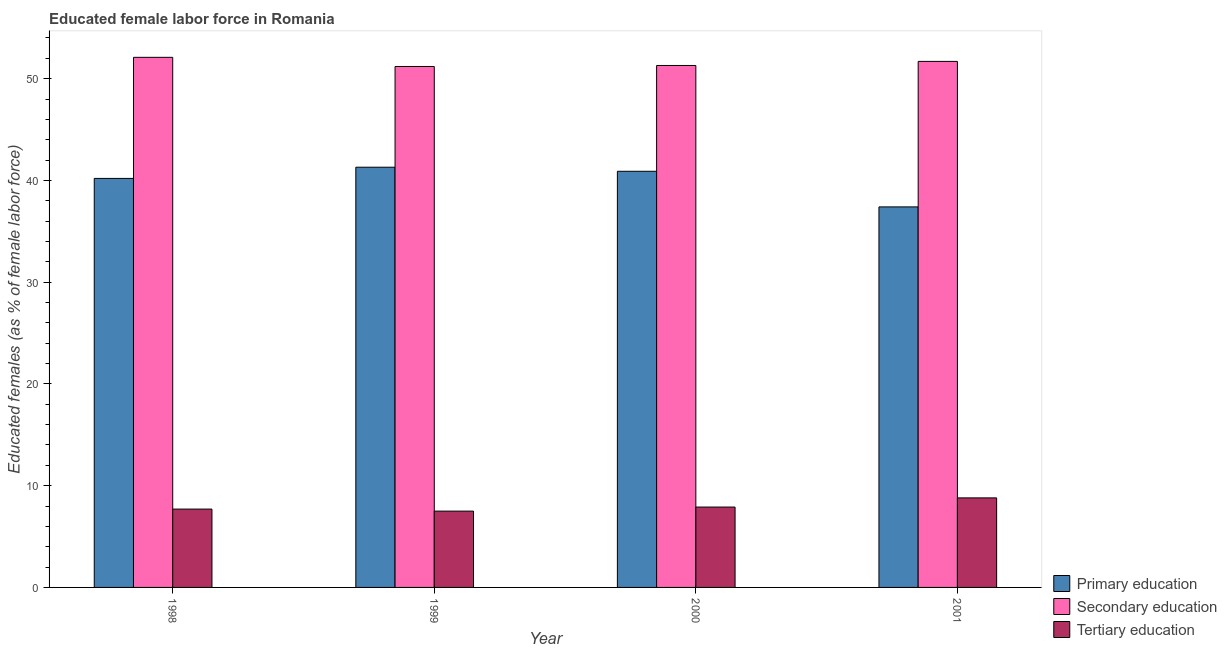How many groups of bars are there?
Keep it short and to the point. 4. Are the number of bars per tick equal to the number of legend labels?
Your response must be concise. Yes. Are the number of bars on each tick of the X-axis equal?
Make the answer very short. Yes. How many bars are there on the 4th tick from the left?
Provide a succinct answer. 3. What is the label of the 3rd group of bars from the left?
Offer a terse response. 2000. What is the percentage of female labor force who received tertiary education in 2000?
Ensure brevity in your answer.  7.9. Across all years, what is the maximum percentage of female labor force who received primary education?
Offer a very short reply. 41.3. Across all years, what is the minimum percentage of female labor force who received secondary education?
Keep it short and to the point. 51.2. What is the total percentage of female labor force who received secondary education in the graph?
Offer a very short reply. 206.3. What is the difference between the percentage of female labor force who received tertiary education in 1999 and that in 2000?
Ensure brevity in your answer.  -0.4. What is the difference between the percentage of female labor force who received secondary education in 1999 and the percentage of female labor force who received primary education in 2001?
Your response must be concise. -0.5. What is the average percentage of female labor force who received tertiary education per year?
Ensure brevity in your answer.  7.98. In the year 2000, what is the difference between the percentage of female labor force who received secondary education and percentage of female labor force who received primary education?
Offer a very short reply. 0. In how many years, is the percentage of female labor force who received primary education greater than 16 %?
Your answer should be very brief. 4. What is the ratio of the percentage of female labor force who received primary education in 1998 to that in 2001?
Offer a terse response. 1.07. Is the percentage of female labor force who received tertiary education in 1999 less than that in 2001?
Your response must be concise. Yes. What is the difference between the highest and the second highest percentage of female labor force who received secondary education?
Your answer should be compact. 0.4. What is the difference between the highest and the lowest percentage of female labor force who received primary education?
Provide a short and direct response. 3.9. Is the sum of the percentage of female labor force who received primary education in 1999 and 2001 greater than the maximum percentage of female labor force who received tertiary education across all years?
Provide a short and direct response. Yes. What does the 2nd bar from the left in 1999 represents?
Your response must be concise. Secondary education. What does the 1st bar from the right in 2001 represents?
Offer a very short reply. Tertiary education. Are all the bars in the graph horizontal?
Make the answer very short. No. Where does the legend appear in the graph?
Your response must be concise. Bottom right. How many legend labels are there?
Your answer should be very brief. 3. What is the title of the graph?
Ensure brevity in your answer.  Educated female labor force in Romania. What is the label or title of the X-axis?
Your answer should be very brief. Year. What is the label or title of the Y-axis?
Your answer should be compact. Educated females (as % of female labor force). What is the Educated females (as % of female labor force) in Primary education in 1998?
Give a very brief answer. 40.2. What is the Educated females (as % of female labor force) of Secondary education in 1998?
Offer a terse response. 52.1. What is the Educated females (as % of female labor force) in Tertiary education in 1998?
Your answer should be compact. 7.7. What is the Educated females (as % of female labor force) in Primary education in 1999?
Keep it short and to the point. 41.3. What is the Educated females (as % of female labor force) in Secondary education in 1999?
Offer a very short reply. 51.2. What is the Educated females (as % of female labor force) in Primary education in 2000?
Provide a short and direct response. 40.9. What is the Educated females (as % of female labor force) in Secondary education in 2000?
Offer a terse response. 51.3. What is the Educated females (as % of female labor force) in Tertiary education in 2000?
Offer a very short reply. 7.9. What is the Educated females (as % of female labor force) of Primary education in 2001?
Offer a terse response. 37.4. What is the Educated females (as % of female labor force) of Secondary education in 2001?
Your answer should be very brief. 51.7. What is the Educated females (as % of female labor force) of Tertiary education in 2001?
Provide a short and direct response. 8.8. Across all years, what is the maximum Educated females (as % of female labor force) in Primary education?
Provide a short and direct response. 41.3. Across all years, what is the maximum Educated females (as % of female labor force) of Secondary education?
Your response must be concise. 52.1. Across all years, what is the maximum Educated females (as % of female labor force) in Tertiary education?
Your answer should be compact. 8.8. Across all years, what is the minimum Educated females (as % of female labor force) of Primary education?
Your answer should be compact. 37.4. Across all years, what is the minimum Educated females (as % of female labor force) of Secondary education?
Your answer should be very brief. 51.2. Across all years, what is the minimum Educated females (as % of female labor force) of Tertiary education?
Offer a terse response. 7.5. What is the total Educated females (as % of female labor force) in Primary education in the graph?
Keep it short and to the point. 159.8. What is the total Educated females (as % of female labor force) of Secondary education in the graph?
Offer a terse response. 206.3. What is the total Educated females (as % of female labor force) of Tertiary education in the graph?
Offer a very short reply. 31.9. What is the difference between the Educated females (as % of female labor force) of Primary education in 1998 and that in 1999?
Offer a terse response. -1.1. What is the difference between the Educated females (as % of female labor force) in Secondary education in 1998 and that in 2000?
Offer a very short reply. 0.8. What is the difference between the Educated females (as % of female labor force) of Tertiary education in 1998 and that in 2000?
Provide a short and direct response. -0.2. What is the difference between the Educated females (as % of female labor force) of Secondary education in 1998 and that in 2001?
Keep it short and to the point. 0.4. What is the difference between the Educated females (as % of female labor force) of Secondary education in 1999 and that in 2000?
Your response must be concise. -0.1. What is the difference between the Educated females (as % of female labor force) in Tertiary education in 1999 and that in 2000?
Make the answer very short. -0.4. What is the difference between the Educated females (as % of female labor force) in Primary education in 1999 and that in 2001?
Ensure brevity in your answer.  3.9. What is the difference between the Educated females (as % of female labor force) of Secondary education in 1999 and that in 2001?
Offer a very short reply. -0.5. What is the difference between the Educated females (as % of female labor force) of Primary education in 1998 and the Educated females (as % of female labor force) of Secondary education in 1999?
Your response must be concise. -11. What is the difference between the Educated females (as % of female labor force) in Primary education in 1998 and the Educated females (as % of female labor force) in Tertiary education in 1999?
Offer a terse response. 32.7. What is the difference between the Educated females (as % of female labor force) in Secondary education in 1998 and the Educated females (as % of female labor force) in Tertiary education in 1999?
Your answer should be very brief. 44.6. What is the difference between the Educated females (as % of female labor force) of Primary education in 1998 and the Educated females (as % of female labor force) of Secondary education in 2000?
Your answer should be compact. -11.1. What is the difference between the Educated females (as % of female labor force) of Primary education in 1998 and the Educated females (as % of female labor force) of Tertiary education in 2000?
Make the answer very short. 32.3. What is the difference between the Educated females (as % of female labor force) in Secondary education in 1998 and the Educated females (as % of female labor force) in Tertiary education in 2000?
Ensure brevity in your answer.  44.2. What is the difference between the Educated females (as % of female labor force) in Primary education in 1998 and the Educated females (as % of female labor force) in Tertiary education in 2001?
Ensure brevity in your answer.  31.4. What is the difference between the Educated females (as % of female labor force) of Secondary education in 1998 and the Educated females (as % of female labor force) of Tertiary education in 2001?
Give a very brief answer. 43.3. What is the difference between the Educated females (as % of female labor force) of Primary education in 1999 and the Educated females (as % of female labor force) of Tertiary education in 2000?
Your answer should be compact. 33.4. What is the difference between the Educated females (as % of female labor force) of Secondary education in 1999 and the Educated females (as % of female labor force) of Tertiary education in 2000?
Offer a very short reply. 43.3. What is the difference between the Educated females (as % of female labor force) of Primary education in 1999 and the Educated females (as % of female labor force) of Tertiary education in 2001?
Your answer should be very brief. 32.5. What is the difference between the Educated females (as % of female labor force) in Secondary education in 1999 and the Educated females (as % of female labor force) in Tertiary education in 2001?
Your answer should be very brief. 42.4. What is the difference between the Educated females (as % of female labor force) in Primary education in 2000 and the Educated females (as % of female labor force) in Tertiary education in 2001?
Your response must be concise. 32.1. What is the difference between the Educated females (as % of female labor force) in Secondary education in 2000 and the Educated females (as % of female labor force) in Tertiary education in 2001?
Your answer should be very brief. 42.5. What is the average Educated females (as % of female labor force) in Primary education per year?
Your response must be concise. 39.95. What is the average Educated females (as % of female labor force) of Secondary education per year?
Your answer should be compact. 51.58. What is the average Educated females (as % of female labor force) of Tertiary education per year?
Your answer should be compact. 7.97. In the year 1998, what is the difference between the Educated females (as % of female labor force) of Primary education and Educated females (as % of female labor force) of Tertiary education?
Your answer should be compact. 32.5. In the year 1998, what is the difference between the Educated females (as % of female labor force) of Secondary education and Educated females (as % of female labor force) of Tertiary education?
Give a very brief answer. 44.4. In the year 1999, what is the difference between the Educated females (as % of female labor force) of Primary education and Educated females (as % of female labor force) of Tertiary education?
Your response must be concise. 33.8. In the year 1999, what is the difference between the Educated females (as % of female labor force) in Secondary education and Educated females (as % of female labor force) in Tertiary education?
Offer a very short reply. 43.7. In the year 2000, what is the difference between the Educated females (as % of female labor force) in Primary education and Educated females (as % of female labor force) in Secondary education?
Offer a terse response. -10.4. In the year 2000, what is the difference between the Educated females (as % of female labor force) of Primary education and Educated females (as % of female labor force) of Tertiary education?
Keep it short and to the point. 33. In the year 2000, what is the difference between the Educated females (as % of female labor force) of Secondary education and Educated females (as % of female labor force) of Tertiary education?
Make the answer very short. 43.4. In the year 2001, what is the difference between the Educated females (as % of female labor force) in Primary education and Educated females (as % of female labor force) in Secondary education?
Offer a very short reply. -14.3. In the year 2001, what is the difference between the Educated females (as % of female labor force) in Primary education and Educated females (as % of female labor force) in Tertiary education?
Give a very brief answer. 28.6. In the year 2001, what is the difference between the Educated females (as % of female labor force) in Secondary education and Educated females (as % of female labor force) in Tertiary education?
Ensure brevity in your answer.  42.9. What is the ratio of the Educated females (as % of female labor force) in Primary education in 1998 to that in 1999?
Offer a very short reply. 0.97. What is the ratio of the Educated females (as % of female labor force) of Secondary education in 1998 to that in 1999?
Your answer should be compact. 1.02. What is the ratio of the Educated females (as % of female labor force) of Tertiary education in 1998 to that in 1999?
Your response must be concise. 1.03. What is the ratio of the Educated females (as % of female labor force) in Primary education in 1998 to that in 2000?
Provide a short and direct response. 0.98. What is the ratio of the Educated females (as % of female labor force) of Secondary education in 1998 to that in 2000?
Your answer should be very brief. 1.02. What is the ratio of the Educated females (as % of female labor force) in Tertiary education in 1998 to that in 2000?
Provide a short and direct response. 0.97. What is the ratio of the Educated females (as % of female labor force) of Primary education in 1998 to that in 2001?
Offer a terse response. 1.07. What is the ratio of the Educated females (as % of female labor force) in Secondary education in 1998 to that in 2001?
Your answer should be compact. 1.01. What is the ratio of the Educated females (as % of female labor force) of Tertiary education in 1998 to that in 2001?
Your answer should be compact. 0.88. What is the ratio of the Educated females (as % of female labor force) of Primary education in 1999 to that in 2000?
Keep it short and to the point. 1.01. What is the ratio of the Educated females (as % of female labor force) in Tertiary education in 1999 to that in 2000?
Your answer should be compact. 0.95. What is the ratio of the Educated females (as % of female labor force) in Primary education in 1999 to that in 2001?
Make the answer very short. 1.1. What is the ratio of the Educated females (as % of female labor force) of Secondary education in 1999 to that in 2001?
Give a very brief answer. 0.99. What is the ratio of the Educated females (as % of female labor force) in Tertiary education in 1999 to that in 2001?
Your response must be concise. 0.85. What is the ratio of the Educated females (as % of female labor force) in Primary education in 2000 to that in 2001?
Provide a succinct answer. 1.09. What is the ratio of the Educated females (as % of female labor force) in Secondary education in 2000 to that in 2001?
Your answer should be very brief. 0.99. What is the ratio of the Educated females (as % of female labor force) in Tertiary education in 2000 to that in 2001?
Your response must be concise. 0.9. What is the difference between the highest and the second highest Educated females (as % of female labor force) in Primary education?
Your answer should be compact. 0.4. What is the difference between the highest and the second highest Educated females (as % of female labor force) of Secondary education?
Your response must be concise. 0.4. What is the difference between the highest and the second highest Educated females (as % of female labor force) of Tertiary education?
Your answer should be compact. 0.9. What is the difference between the highest and the lowest Educated females (as % of female labor force) of Tertiary education?
Your response must be concise. 1.3. 